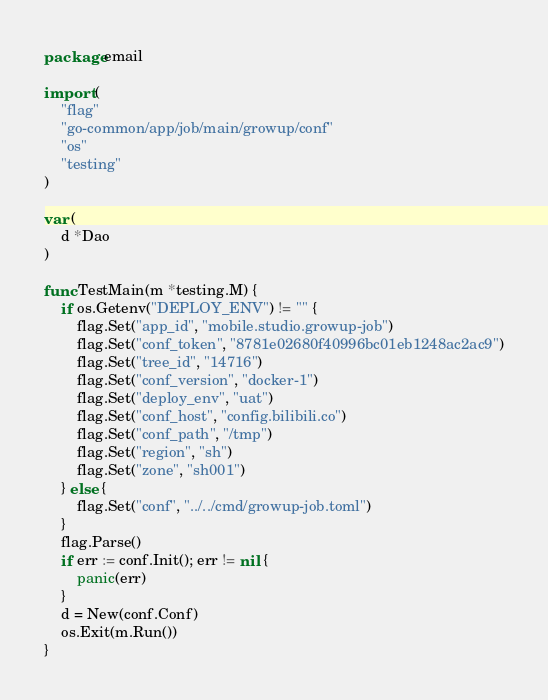<code> <loc_0><loc_0><loc_500><loc_500><_Go_>package email

import (
	"flag"
	"go-common/app/job/main/growup/conf"
	"os"
	"testing"
)

var (
	d *Dao
)

func TestMain(m *testing.M) {
	if os.Getenv("DEPLOY_ENV") != "" {
		flag.Set("app_id", "mobile.studio.growup-job")
		flag.Set("conf_token", "8781e02680f40996bc01eb1248ac2ac9")
		flag.Set("tree_id", "14716")
		flag.Set("conf_version", "docker-1")
		flag.Set("deploy_env", "uat")
		flag.Set("conf_host", "config.bilibili.co")
		flag.Set("conf_path", "/tmp")
		flag.Set("region", "sh")
		flag.Set("zone", "sh001")
	} else {
		flag.Set("conf", "../../cmd/growup-job.toml")
	}
	flag.Parse()
	if err := conf.Init(); err != nil {
		panic(err)
	}
	d = New(conf.Conf)
	os.Exit(m.Run())
}
</code> 